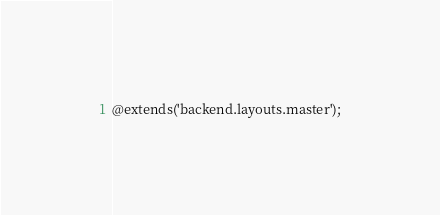<code> <loc_0><loc_0><loc_500><loc_500><_PHP_>@extends('backend.layouts.master');</code> 